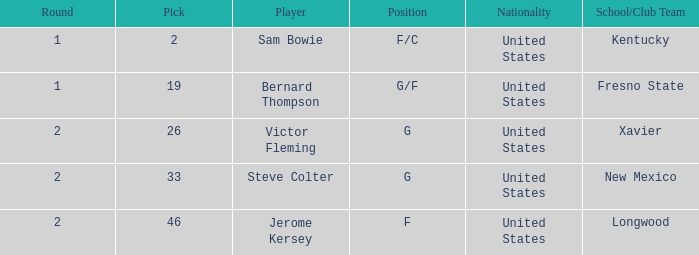What is Player, when Round is "2", and when School/Club Team is "Xavier"? Victor Fleming. 